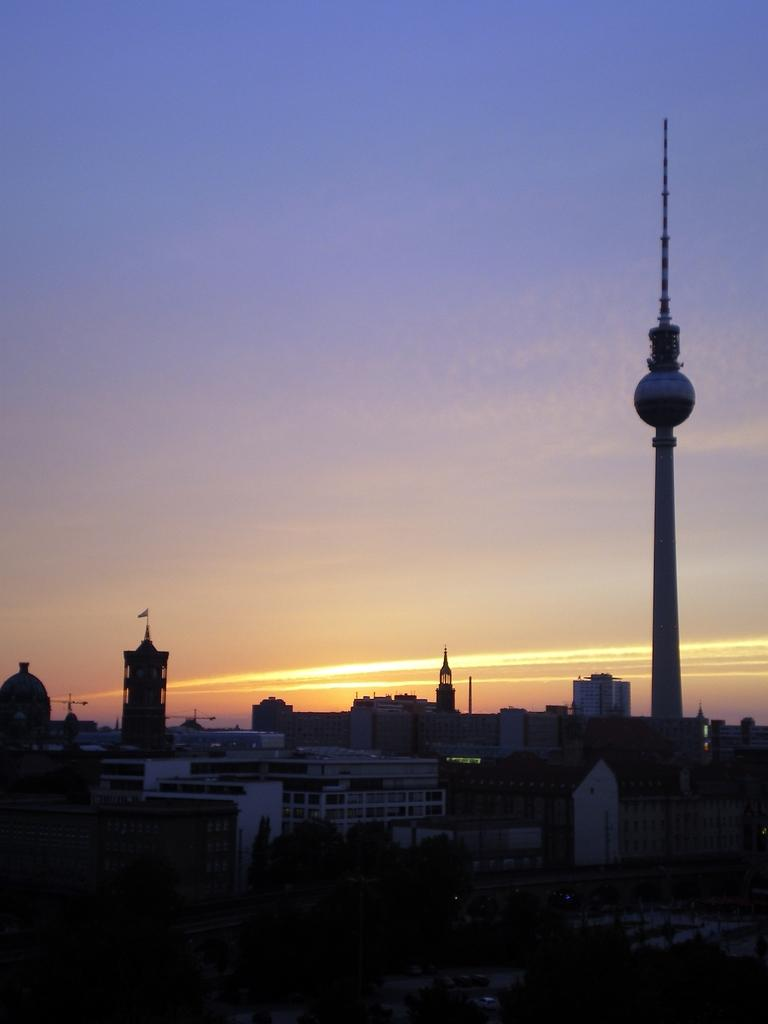What type of structures can be seen in the image? There are buildings in the image. What other natural elements are present in the image? There are trees in the image. What specific feature stands out among the buildings? There is a tower in the image. What can be seen in the distance in the image? The sky is visible in the background of the image. Where is the plate located in the image? There is no plate present in the image. How does the crowd interact with the buildings in the image? There is no crowd present in the image; it only features buildings, trees, a tower, and the sky. 